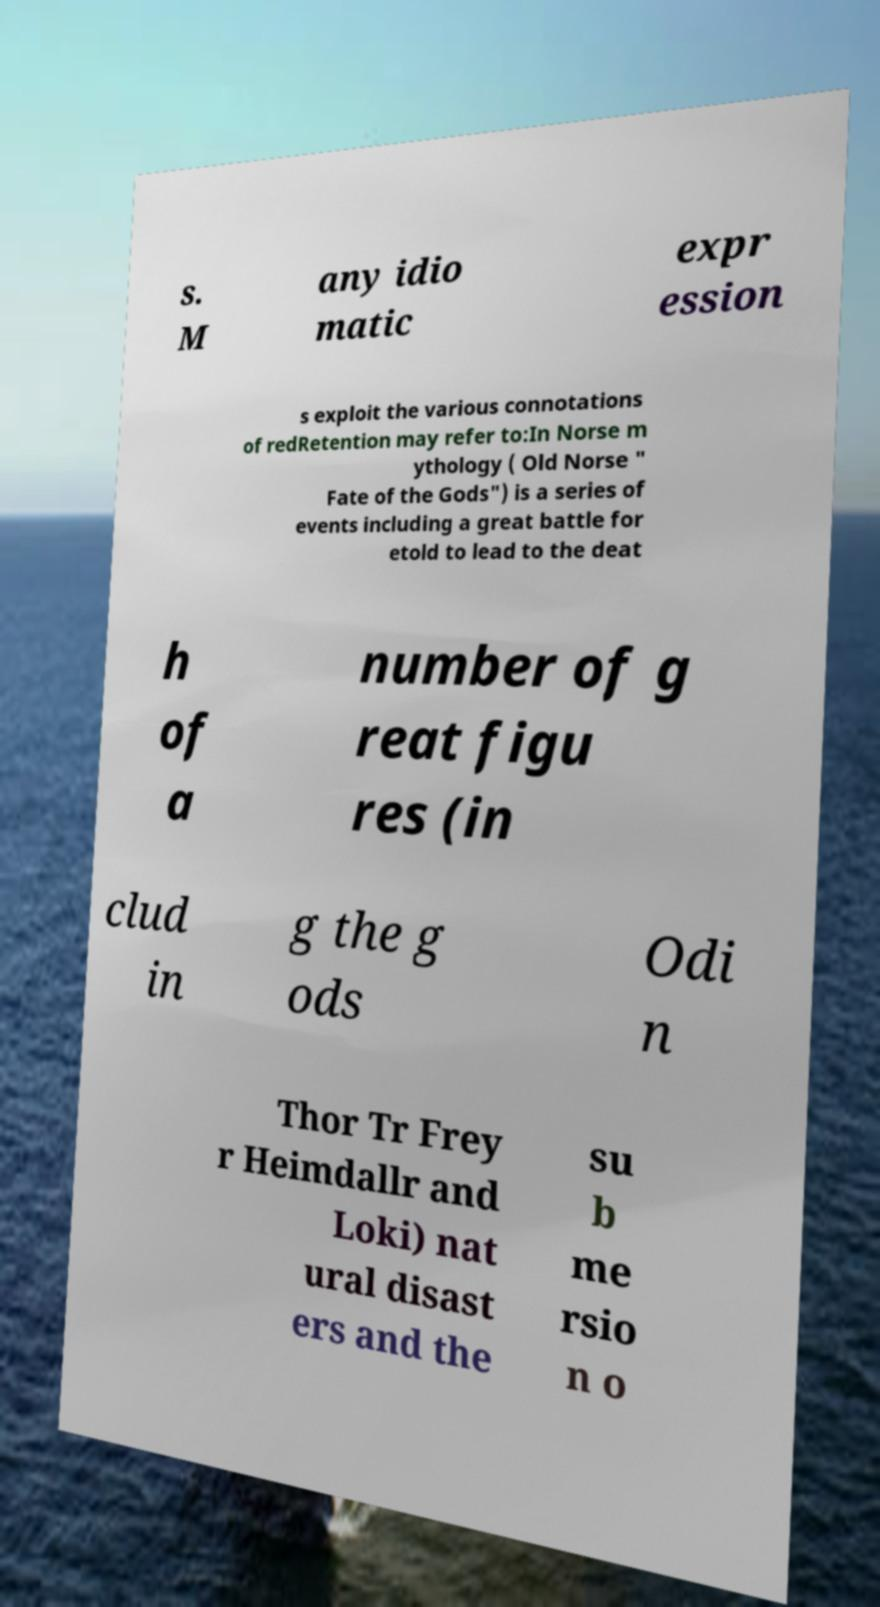Can you accurately transcribe the text from the provided image for me? s. M any idio matic expr ession s exploit the various connotations of redRetention may refer to:In Norse m ythology ( Old Norse " Fate of the Gods") is a series of events including a great battle for etold to lead to the deat h of a number of g reat figu res (in clud in g the g ods Odi n Thor Tr Frey r Heimdallr and Loki) nat ural disast ers and the su b me rsio n o 